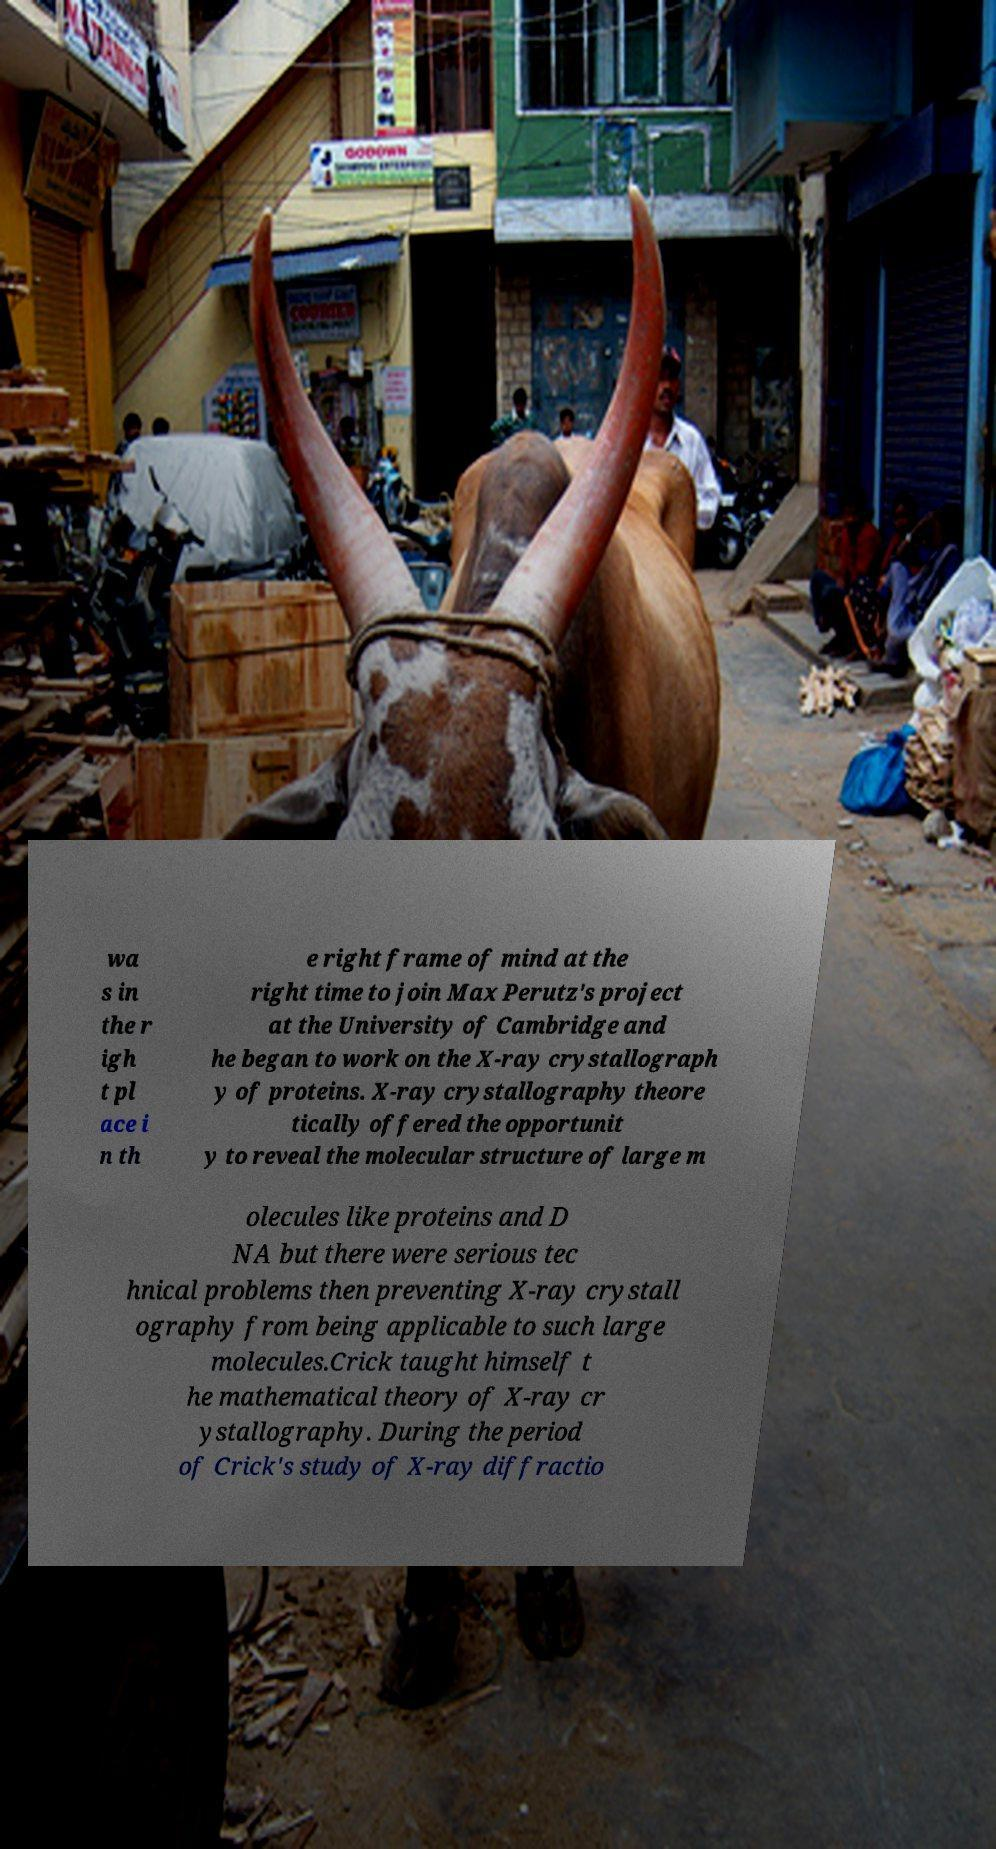For documentation purposes, I need the text within this image transcribed. Could you provide that? wa s in the r igh t pl ace i n th e right frame of mind at the right time to join Max Perutz's project at the University of Cambridge and he began to work on the X-ray crystallograph y of proteins. X-ray crystallography theore tically offered the opportunit y to reveal the molecular structure of large m olecules like proteins and D NA but there were serious tec hnical problems then preventing X-ray crystall ography from being applicable to such large molecules.Crick taught himself t he mathematical theory of X-ray cr ystallography. During the period of Crick's study of X-ray diffractio 